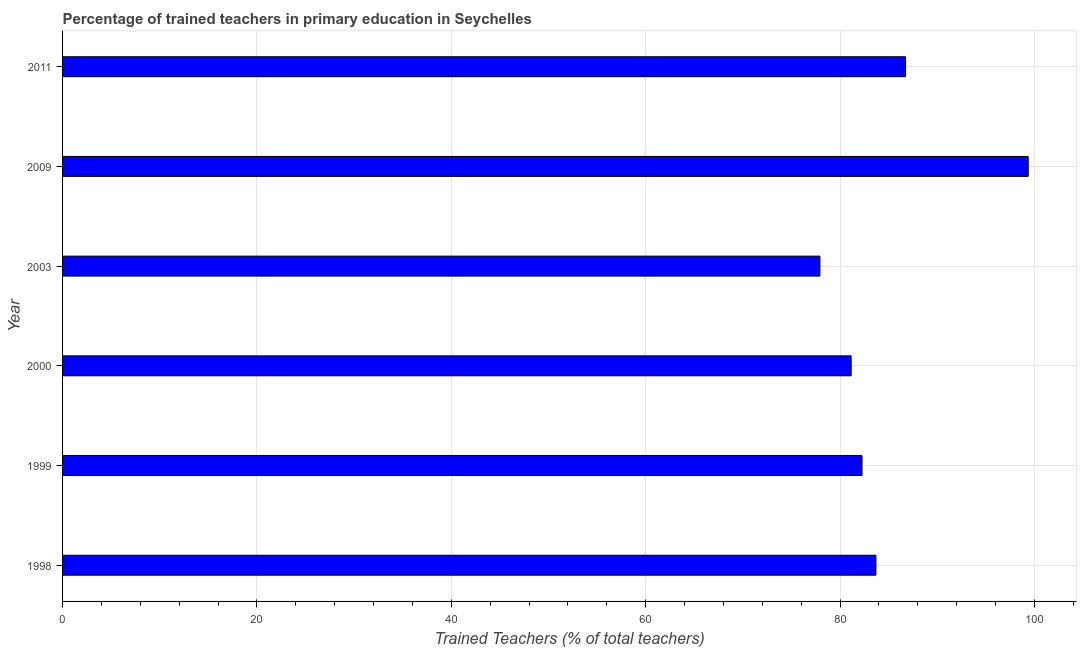Does the graph contain grids?
Provide a short and direct response. Yes. What is the title of the graph?
Offer a terse response. Percentage of trained teachers in primary education in Seychelles. What is the label or title of the X-axis?
Your response must be concise. Trained Teachers (% of total teachers). What is the label or title of the Y-axis?
Give a very brief answer. Year. What is the percentage of trained teachers in 2011?
Keep it short and to the point. 86.74. Across all years, what is the maximum percentage of trained teachers?
Your response must be concise. 99.36. Across all years, what is the minimum percentage of trained teachers?
Keep it short and to the point. 77.93. In which year was the percentage of trained teachers minimum?
Your answer should be compact. 2003. What is the sum of the percentage of trained teachers?
Offer a terse response. 511.11. What is the difference between the percentage of trained teachers in 2003 and 2009?
Your answer should be compact. -21.43. What is the average percentage of trained teachers per year?
Give a very brief answer. 85.19. What is the median percentage of trained teachers?
Ensure brevity in your answer.  82.97. In how many years, is the percentage of trained teachers greater than 12 %?
Offer a very short reply. 6. Do a majority of the years between 2003 and 2000 (inclusive) have percentage of trained teachers greater than 92 %?
Your answer should be compact. No. Is the percentage of trained teachers in 2003 less than that in 2011?
Ensure brevity in your answer.  Yes. What is the difference between the highest and the second highest percentage of trained teachers?
Offer a terse response. 12.62. What is the difference between the highest and the lowest percentage of trained teachers?
Make the answer very short. 21.43. In how many years, is the percentage of trained teachers greater than the average percentage of trained teachers taken over all years?
Offer a very short reply. 2. What is the difference between two consecutive major ticks on the X-axis?
Offer a very short reply. 20. What is the Trained Teachers (% of total teachers) of 1998?
Offer a terse response. 83.69. What is the Trained Teachers (% of total teachers) in 1999?
Your answer should be compact. 82.26. What is the Trained Teachers (% of total teachers) in 2000?
Offer a terse response. 81.14. What is the Trained Teachers (% of total teachers) in 2003?
Ensure brevity in your answer.  77.93. What is the Trained Teachers (% of total teachers) of 2009?
Offer a very short reply. 99.36. What is the Trained Teachers (% of total teachers) in 2011?
Your answer should be very brief. 86.74. What is the difference between the Trained Teachers (% of total teachers) in 1998 and 1999?
Provide a succinct answer. 1.43. What is the difference between the Trained Teachers (% of total teachers) in 1998 and 2000?
Offer a very short reply. 2.55. What is the difference between the Trained Teachers (% of total teachers) in 1998 and 2003?
Ensure brevity in your answer.  5.76. What is the difference between the Trained Teachers (% of total teachers) in 1998 and 2009?
Give a very brief answer. -15.67. What is the difference between the Trained Teachers (% of total teachers) in 1998 and 2011?
Provide a succinct answer. -3.05. What is the difference between the Trained Teachers (% of total teachers) in 1999 and 2000?
Offer a terse response. 1.12. What is the difference between the Trained Teachers (% of total teachers) in 1999 and 2003?
Make the answer very short. 4.33. What is the difference between the Trained Teachers (% of total teachers) in 1999 and 2009?
Make the answer very short. -17.1. What is the difference between the Trained Teachers (% of total teachers) in 1999 and 2011?
Your answer should be very brief. -4.48. What is the difference between the Trained Teachers (% of total teachers) in 2000 and 2003?
Provide a short and direct response. 3.21. What is the difference between the Trained Teachers (% of total teachers) in 2000 and 2009?
Offer a very short reply. -18.22. What is the difference between the Trained Teachers (% of total teachers) in 2000 and 2011?
Make the answer very short. -5.6. What is the difference between the Trained Teachers (% of total teachers) in 2003 and 2009?
Keep it short and to the point. -21.43. What is the difference between the Trained Teachers (% of total teachers) in 2003 and 2011?
Ensure brevity in your answer.  -8.81. What is the difference between the Trained Teachers (% of total teachers) in 2009 and 2011?
Your answer should be compact. 12.62. What is the ratio of the Trained Teachers (% of total teachers) in 1998 to that in 2000?
Your response must be concise. 1.03. What is the ratio of the Trained Teachers (% of total teachers) in 1998 to that in 2003?
Make the answer very short. 1.07. What is the ratio of the Trained Teachers (% of total teachers) in 1998 to that in 2009?
Provide a short and direct response. 0.84. What is the ratio of the Trained Teachers (% of total teachers) in 1999 to that in 2003?
Offer a terse response. 1.06. What is the ratio of the Trained Teachers (% of total teachers) in 1999 to that in 2009?
Ensure brevity in your answer.  0.83. What is the ratio of the Trained Teachers (% of total teachers) in 1999 to that in 2011?
Offer a terse response. 0.95. What is the ratio of the Trained Teachers (% of total teachers) in 2000 to that in 2003?
Your answer should be very brief. 1.04. What is the ratio of the Trained Teachers (% of total teachers) in 2000 to that in 2009?
Make the answer very short. 0.82. What is the ratio of the Trained Teachers (% of total teachers) in 2000 to that in 2011?
Provide a short and direct response. 0.94. What is the ratio of the Trained Teachers (% of total teachers) in 2003 to that in 2009?
Keep it short and to the point. 0.78. What is the ratio of the Trained Teachers (% of total teachers) in 2003 to that in 2011?
Ensure brevity in your answer.  0.9. What is the ratio of the Trained Teachers (% of total teachers) in 2009 to that in 2011?
Provide a succinct answer. 1.15. 